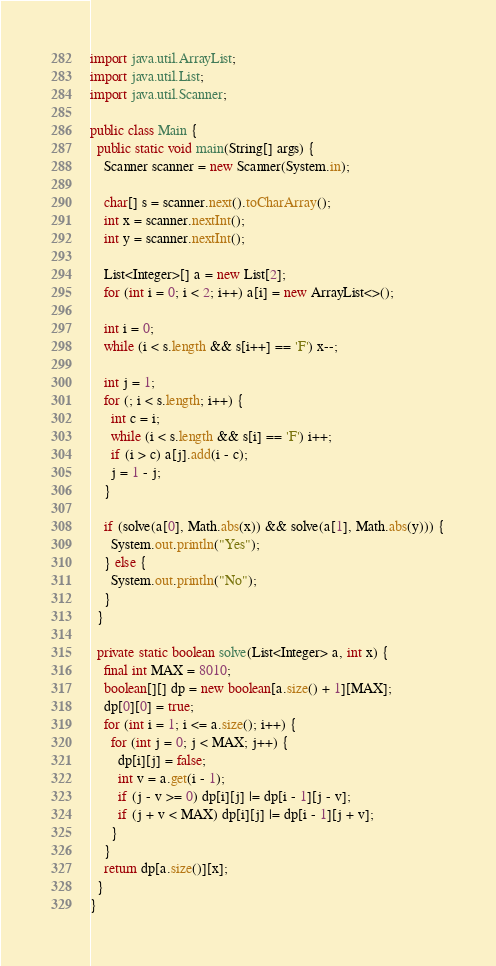<code> <loc_0><loc_0><loc_500><loc_500><_Java_>import java.util.ArrayList;
import java.util.List;
import java.util.Scanner;

public class Main {
  public static void main(String[] args) {
    Scanner scanner = new Scanner(System.in);

    char[] s = scanner.next().toCharArray();
    int x = scanner.nextInt();
    int y = scanner.nextInt();

    List<Integer>[] a = new List[2];
    for (int i = 0; i < 2; i++) a[i] = new ArrayList<>();

    int i = 0;
    while (i < s.length && s[i++] == 'F') x--;

    int j = 1;
    for (; i < s.length; i++) {
      int c = i;
      while (i < s.length && s[i] == 'F') i++;
      if (i > c) a[j].add(i - c);
      j = 1 - j;
    }

    if (solve(a[0], Math.abs(x)) && solve(a[1], Math.abs(y))) {
      System.out.println("Yes");
    } else {
      System.out.println("No");
    }
  }

  private static boolean solve(List<Integer> a, int x) {
    final int MAX = 8010;
    boolean[][] dp = new boolean[a.size() + 1][MAX];
    dp[0][0] = true;
    for (int i = 1; i <= a.size(); i++) {
      for (int j = 0; j < MAX; j++) {
        dp[i][j] = false;
        int v = a.get(i - 1);
        if (j - v >= 0) dp[i][j] |= dp[i - 1][j - v];
        if (j + v < MAX) dp[i][j] |= dp[i - 1][j + v];
      }
    }
    return dp[a.size()][x];
  }
}
</code> 